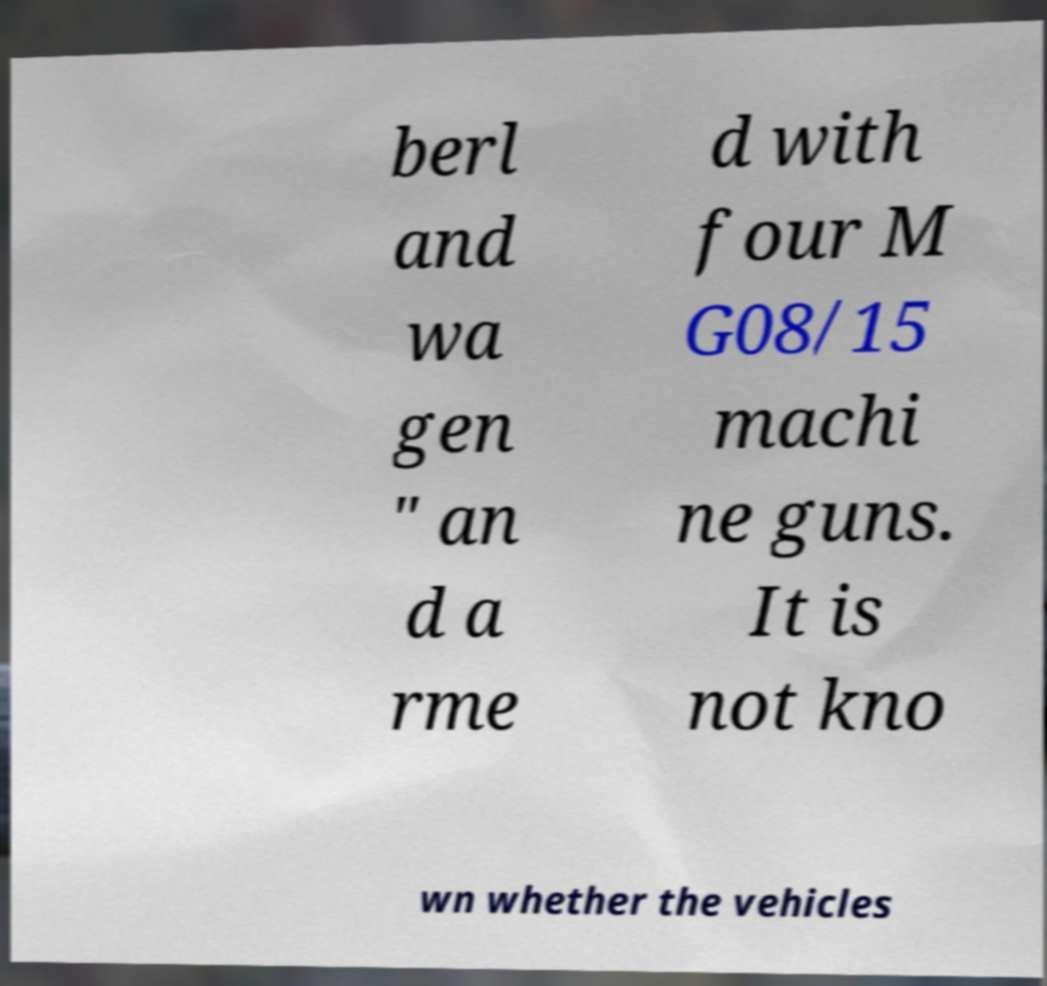Please read and relay the text visible in this image. What does it say? berl and wa gen " an d a rme d with four M G08/15 machi ne guns. It is not kno wn whether the vehicles 